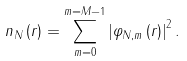Convert formula to latex. <formula><loc_0><loc_0><loc_500><loc_500>n _ { N } \left ( r \right ) = \sum _ { m = 0 } ^ { m = M - 1 } \left | \varphi _ { N , m } \left ( r \right ) \right | ^ { 2 } .</formula> 